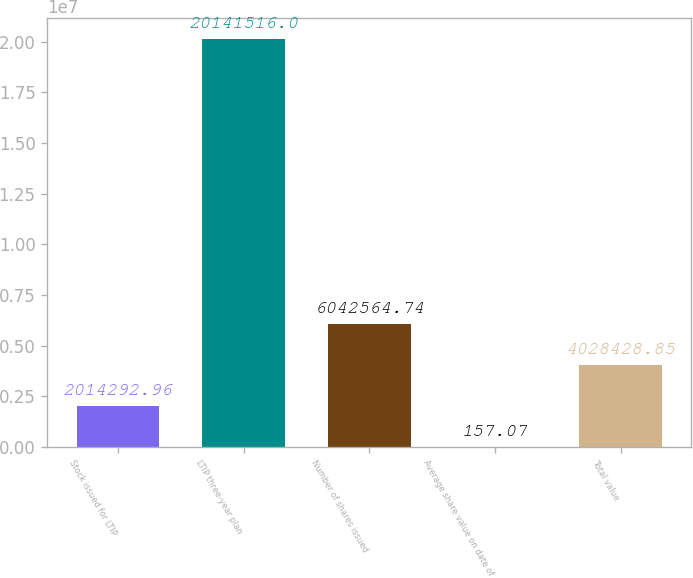<chart> <loc_0><loc_0><loc_500><loc_500><bar_chart><fcel>Stock issued for LTIP<fcel>LTIP three-year plan<fcel>Number of shares issued<fcel>Average share value on date of<fcel>Total value<nl><fcel>2.01429e+06<fcel>2.01415e+07<fcel>6.04256e+06<fcel>157.07<fcel>4.02843e+06<nl></chart> 